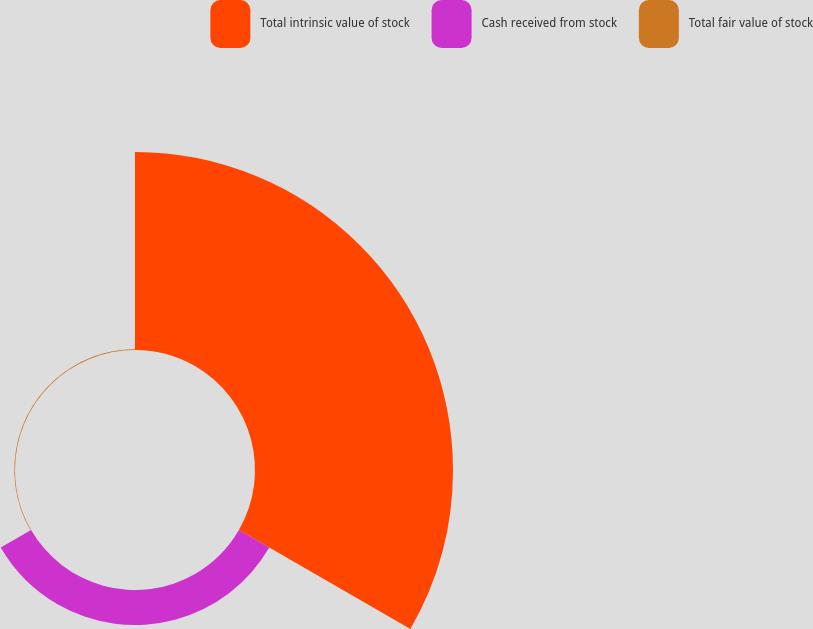Convert chart to OTSL. <chart><loc_0><loc_0><loc_500><loc_500><pie_chart><fcel>Total intrinsic value of stock<fcel>Cash received from stock<fcel>Total fair value of stock<nl><fcel>84.71%<fcel>14.98%<fcel>0.31%<nl></chart> 